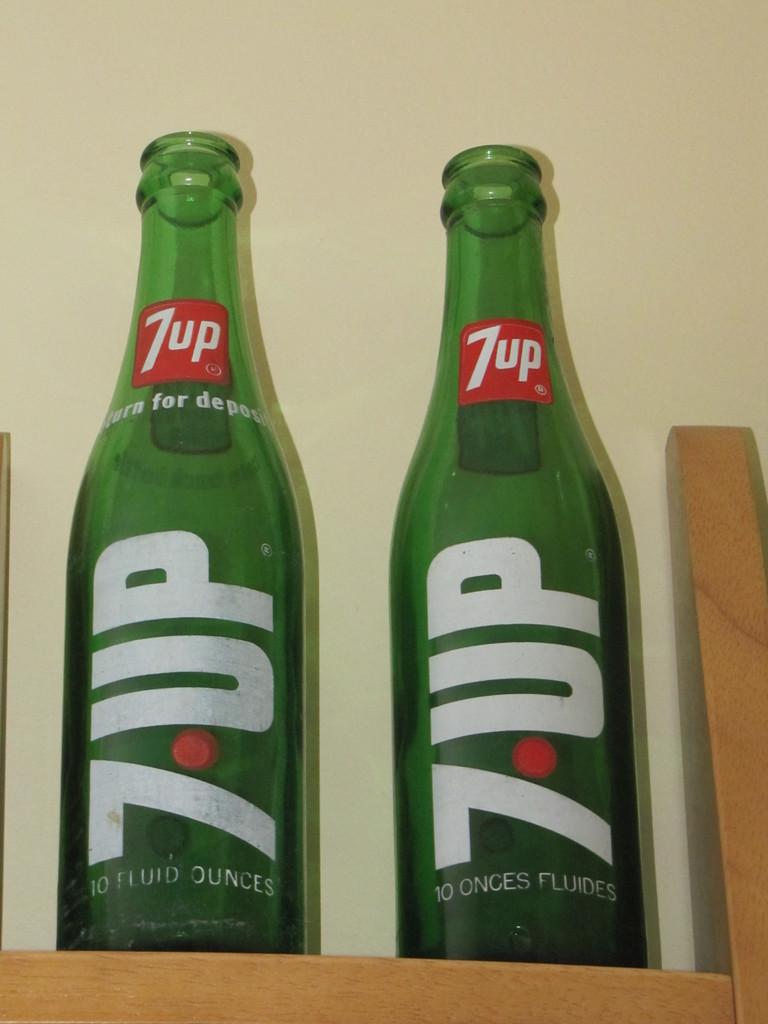How many fluid ounces of 7-up were in each bottle?
Provide a short and direct response. 10. What brand of soda is this?
Your answer should be compact. 7up. 